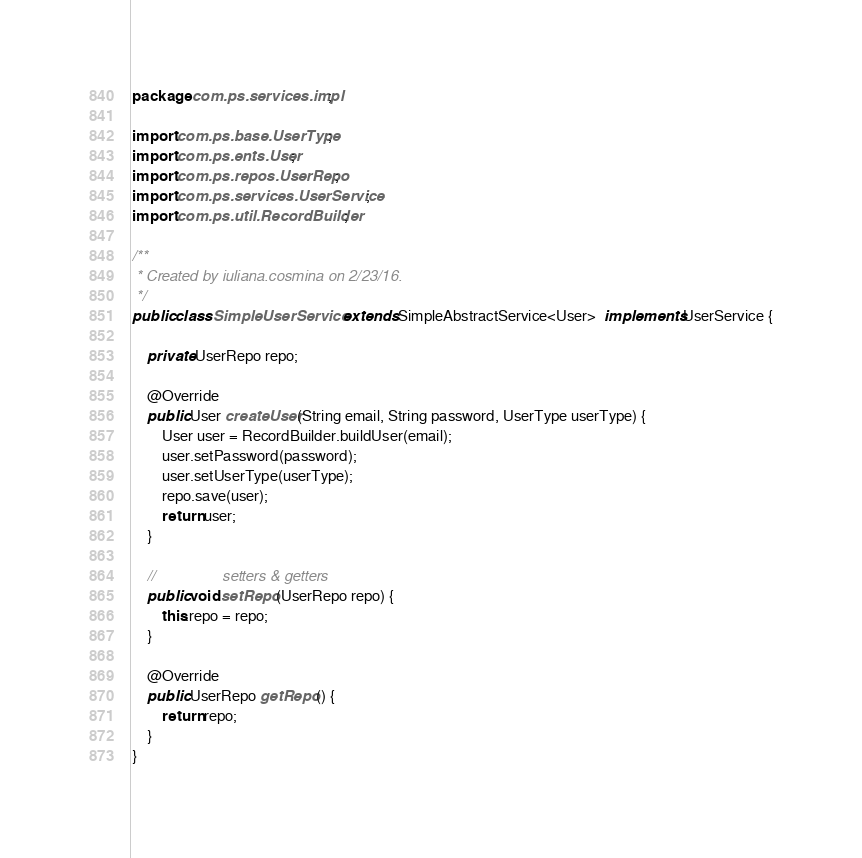<code> <loc_0><loc_0><loc_500><loc_500><_Java_>package com.ps.services.impl;

import com.ps.base.UserType;
import com.ps.ents.User;
import com.ps.repos.UserRepo;
import com.ps.services.UserService;
import com.ps.util.RecordBuilder;

/**
 * Created by iuliana.cosmina on 2/23/16.
 */
public class SimpleUserService extends SimpleAbstractService<User>  implements UserService {

    private UserRepo repo;

    @Override
    public User createUser(String email, String password, UserType userType) {
        User user = RecordBuilder.buildUser(email);
        user.setPassword(password);
        user.setUserType(userType);
        repo.save(user);
        return user;
    }

    //                setters & getters
    public void setRepo(UserRepo repo) {
        this.repo = repo;
    }

    @Override
    public UserRepo getRepo() {
        return repo;
    }
}
</code> 